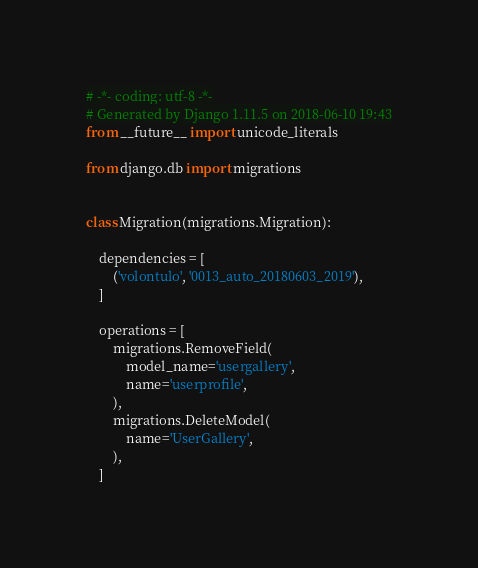<code> <loc_0><loc_0><loc_500><loc_500><_Python_># -*- coding: utf-8 -*-
# Generated by Django 1.11.5 on 2018-06-10 19:43
from __future__ import unicode_literals

from django.db import migrations


class Migration(migrations.Migration):

    dependencies = [
        ('volontulo', '0013_auto_20180603_2019'),
    ]

    operations = [
        migrations.RemoveField(
            model_name='usergallery',
            name='userprofile',
        ),
        migrations.DeleteModel(
            name='UserGallery',
        ),
    ]
</code> 